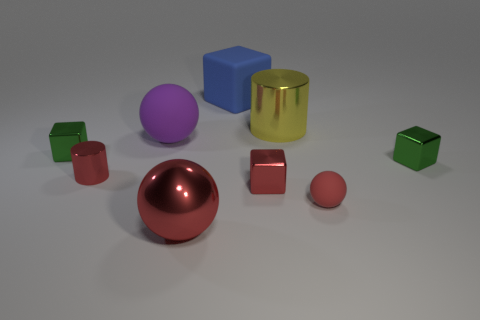Do the green object on the right side of the blue cube and the red metallic cube have the same size?
Keep it short and to the point. Yes. What is the shape of the tiny metal object that is right of the large shiny object behind the tiny red cylinder?
Provide a short and direct response. Cube. What size is the matte ball that is to the left of the big thing that is in front of the red shiny cylinder?
Your answer should be compact. Large. What is the color of the shiny thing in front of the tiny red rubber ball?
Offer a very short reply. Red. The red block that is the same material as the tiny red cylinder is what size?
Provide a succinct answer. Small. What number of large red metallic objects have the same shape as the blue matte thing?
Offer a very short reply. 0. What material is the ball that is the same size as the red metallic block?
Ensure brevity in your answer.  Rubber. Are there any small green cubes that have the same material as the yellow cylinder?
Your answer should be compact. Yes. The block that is both to the right of the big blue object and left of the small red rubber thing is what color?
Give a very brief answer. Red. How many other objects are the same color as the metal ball?
Your answer should be very brief. 3. 